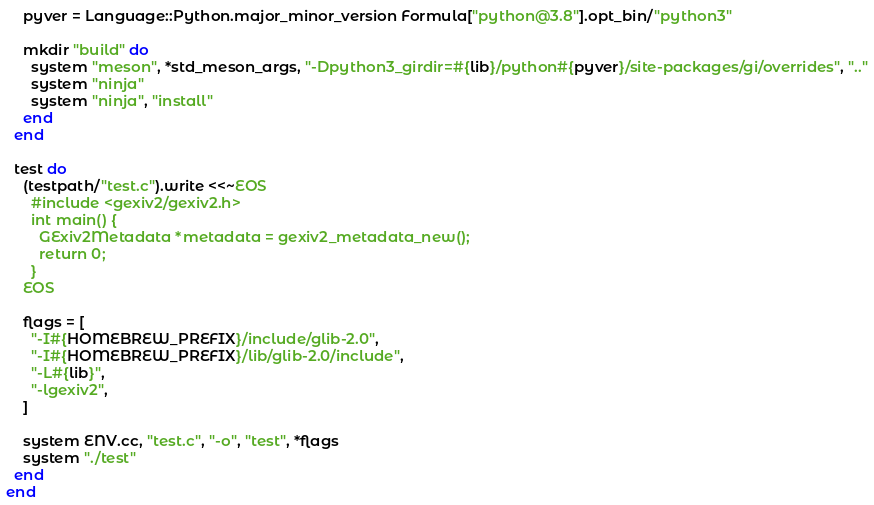<code> <loc_0><loc_0><loc_500><loc_500><_Ruby_>    pyver = Language::Python.major_minor_version Formula["python@3.8"].opt_bin/"python3"

    mkdir "build" do
      system "meson", *std_meson_args, "-Dpython3_girdir=#{lib}/python#{pyver}/site-packages/gi/overrides", ".."
      system "ninja"
      system "ninja", "install"
    end
  end

  test do
    (testpath/"test.c").write <<~EOS
      #include <gexiv2/gexiv2.h>
      int main() {
        GExiv2Metadata *metadata = gexiv2_metadata_new();
        return 0;
      }
    EOS

    flags = [
      "-I#{HOMEBREW_PREFIX}/include/glib-2.0",
      "-I#{HOMEBREW_PREFIX}/lib/glib-2.0/include",
      "-L#{lib}",
      "-lgexiv2",
    ]

    system ENV.cc, "test.c", "-o", "test", *flags
    system "./test"
  end
end
</code> 